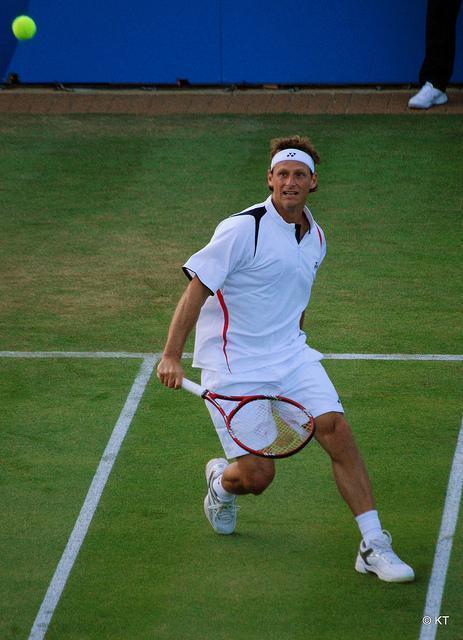How many people are in the picture?
Give a very brief answer. 2. How many bottles of cleaner do you see?
Give a very brief answer. 0. 